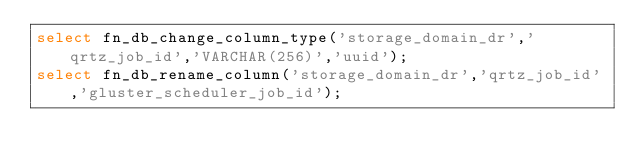Convert code to text. <code><loc_0><loc_0><loc_500><loc_500><_SQL_>select fn_db_change_column_type('storage_domain_dr','qrtz_job_id','VARCHAR(256)','uuid');
select fn_db_rename_column('storage_domain_dr','qrtz_job_id','gluster_scheduler_job_id');
</code> 